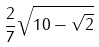Convert formula to latex. <formula><loc_0><loc_0><loc_500><loc_500>\frac { 2 } { 7 } \sqrt { 1 0 - \sqrt { 2 } }</formula> 